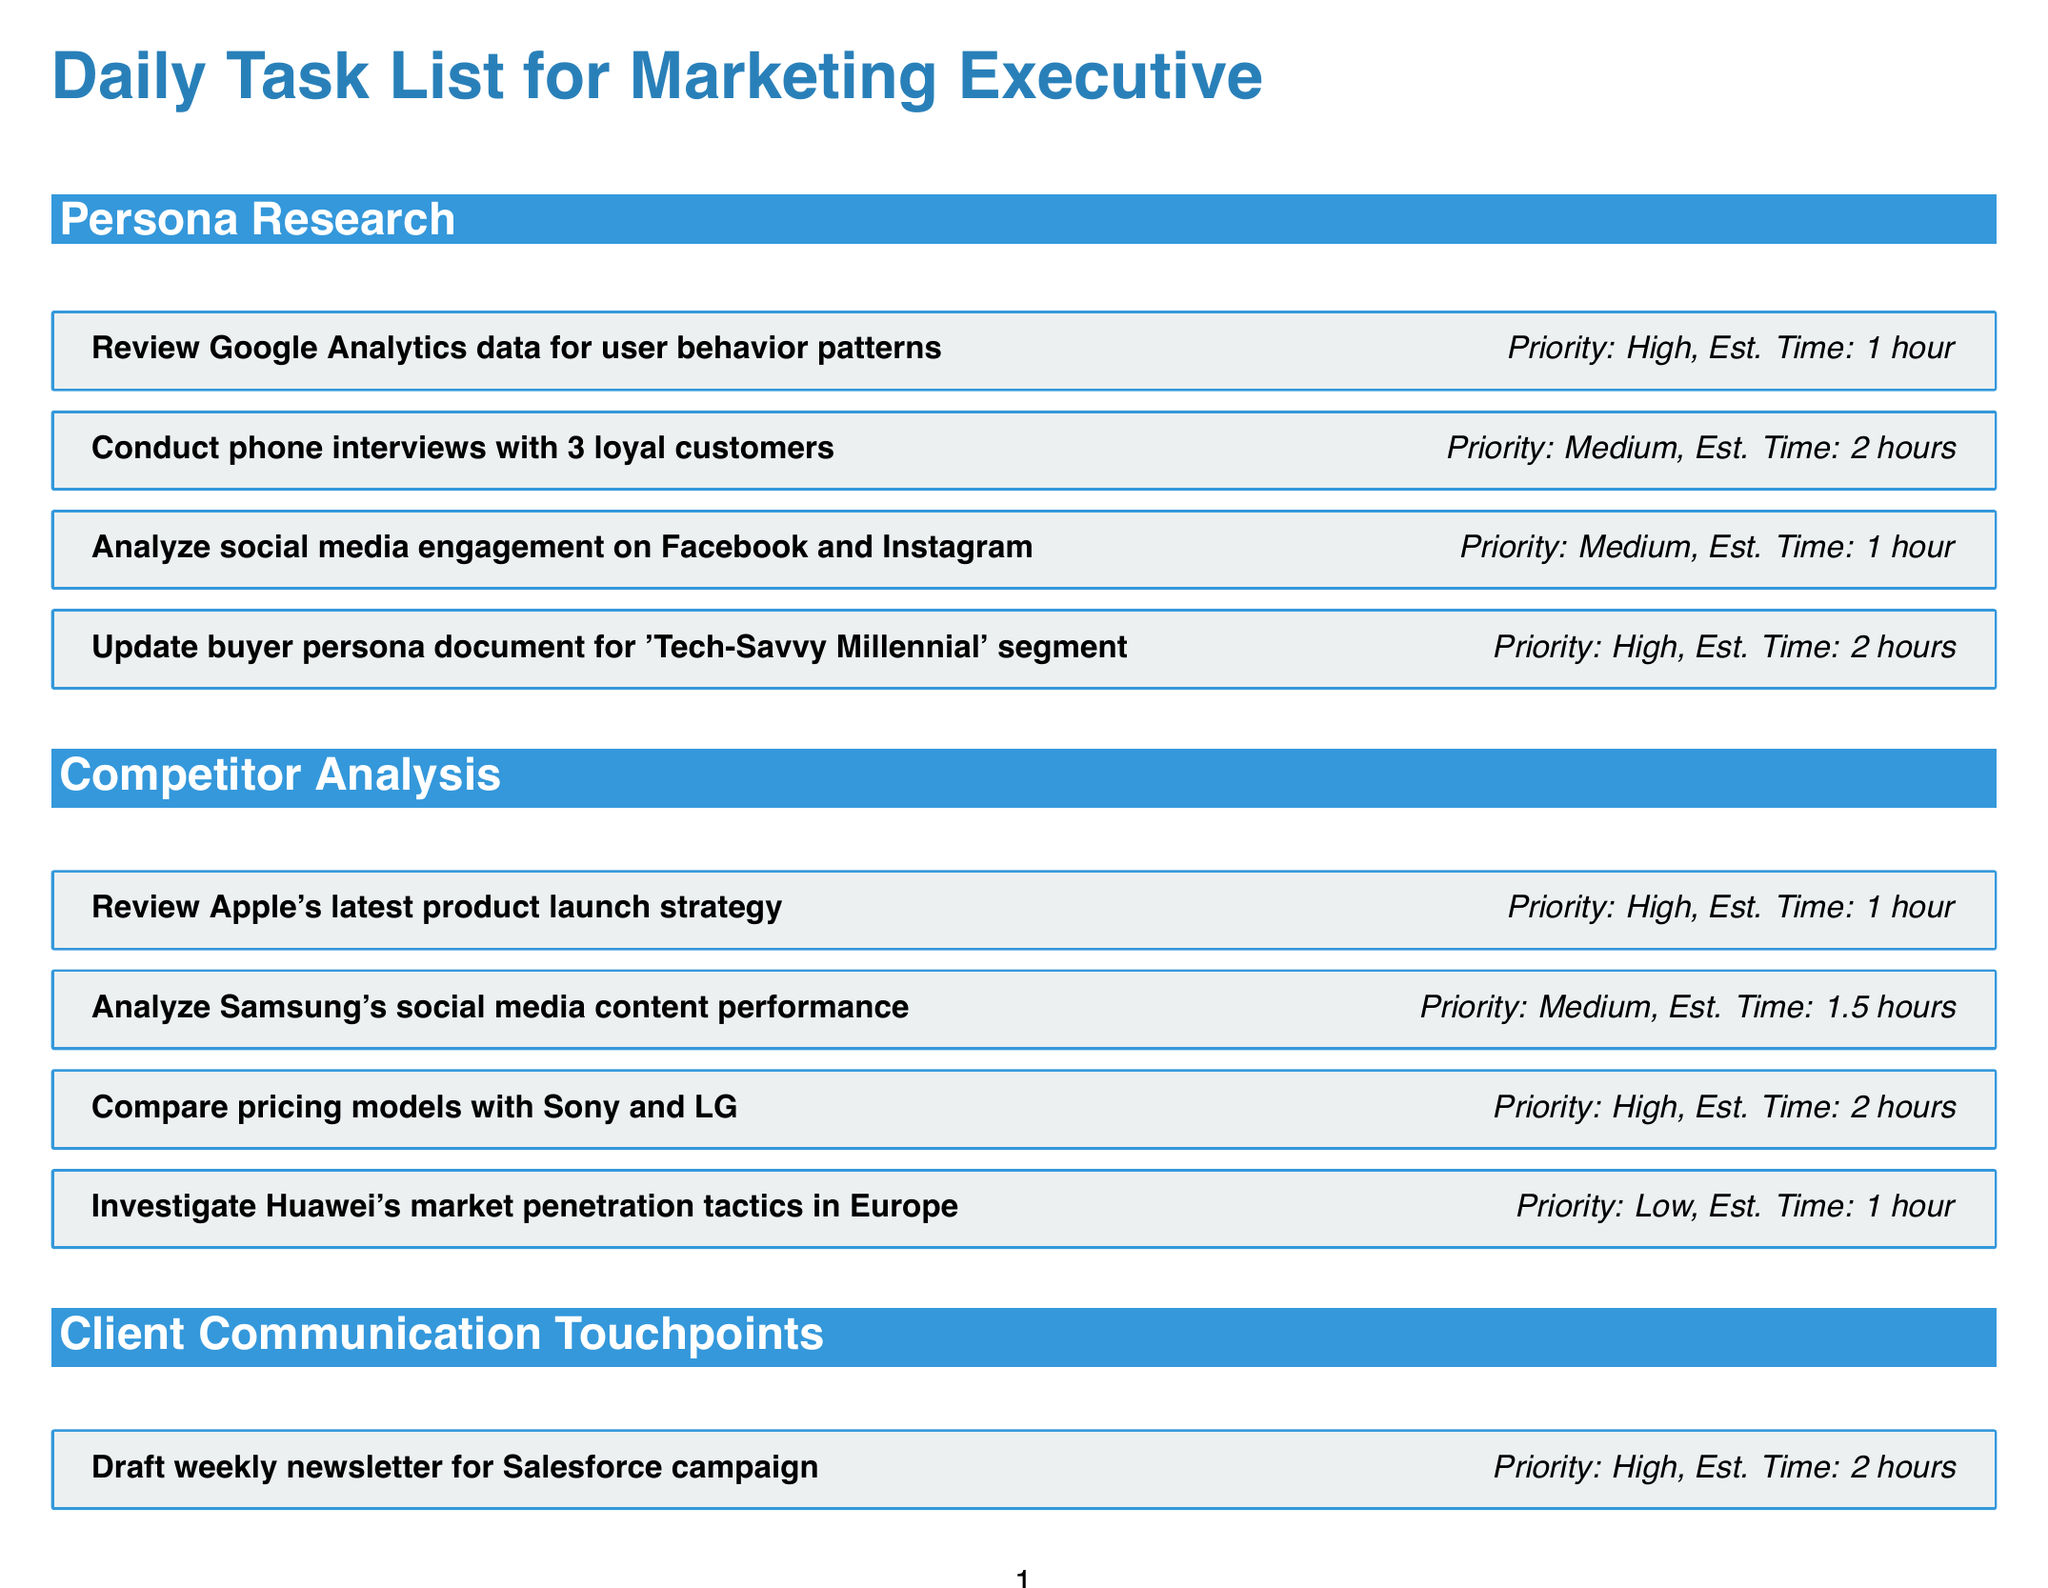What is the estimated time for updating the buyer persona document? The estimated time for updating the buyer persona document is listed in the task under Persona Research.
Answer: 2 hours How many loyal customers will be interviewed for persona research? The task for conducting phone interviews specifies that three loyal customers will be interviewed.
Answer: 3 loyal customers What is the priority level for reviewing Apple's latest product launch strategy? The priority level is stated next to the relevant task under Competitor Analysis.
Answer: High What task requires the longest estimated time in the Client Communication Touchpoints category? The task with the longest estimated time under this category is found by comparing the estimated times for the listed tasks.
Answer: Prepare presentation for Coca-Cola quarterly review meeting Which task in the Competitor Analysis category has low priority? The task with low priority is identified from the list of tasks under Competitor Analysis.
Answer: Investigate Huawei's market penetration tactics in Europe 